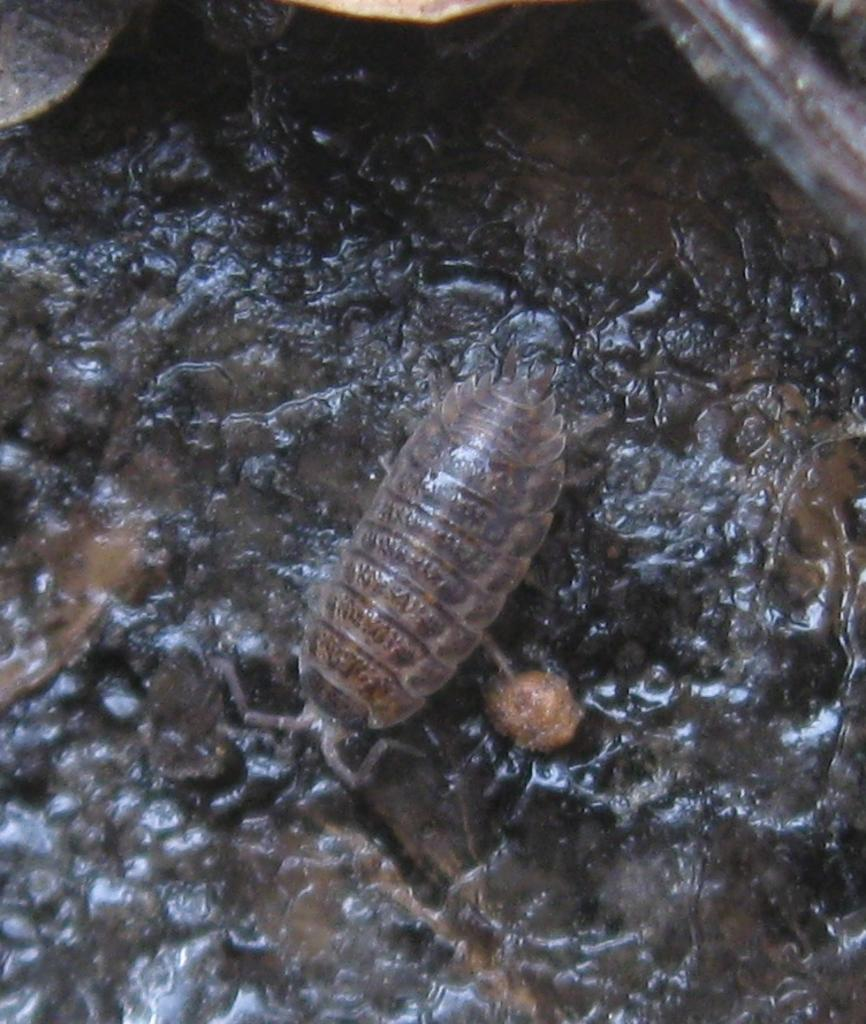What type of creature is in the image? There is an insect in the image. What colors can be seen on the insect? The insect is brown and black in color. What is the insect resting on in the image? The insect is on a black colored surface. What type of guide is present in the image? There is no guide present in the image; it features an insect on a black surface. How many tents can be seen in the image? There are no tents present in the image. 